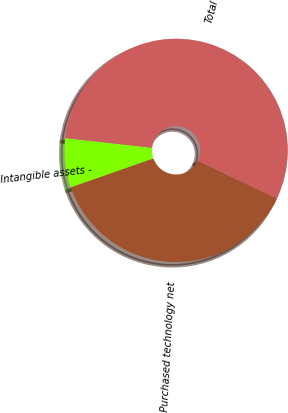<chart> <loc_0><loc_0><loc_500><loc_500><pie_chart><fcel>Purchased technology net<fcel>Intangible assets -<fcel>Total<nl><fcel>37.53%<fcel>7.12%<fcel>55.34%<nl></chart> 